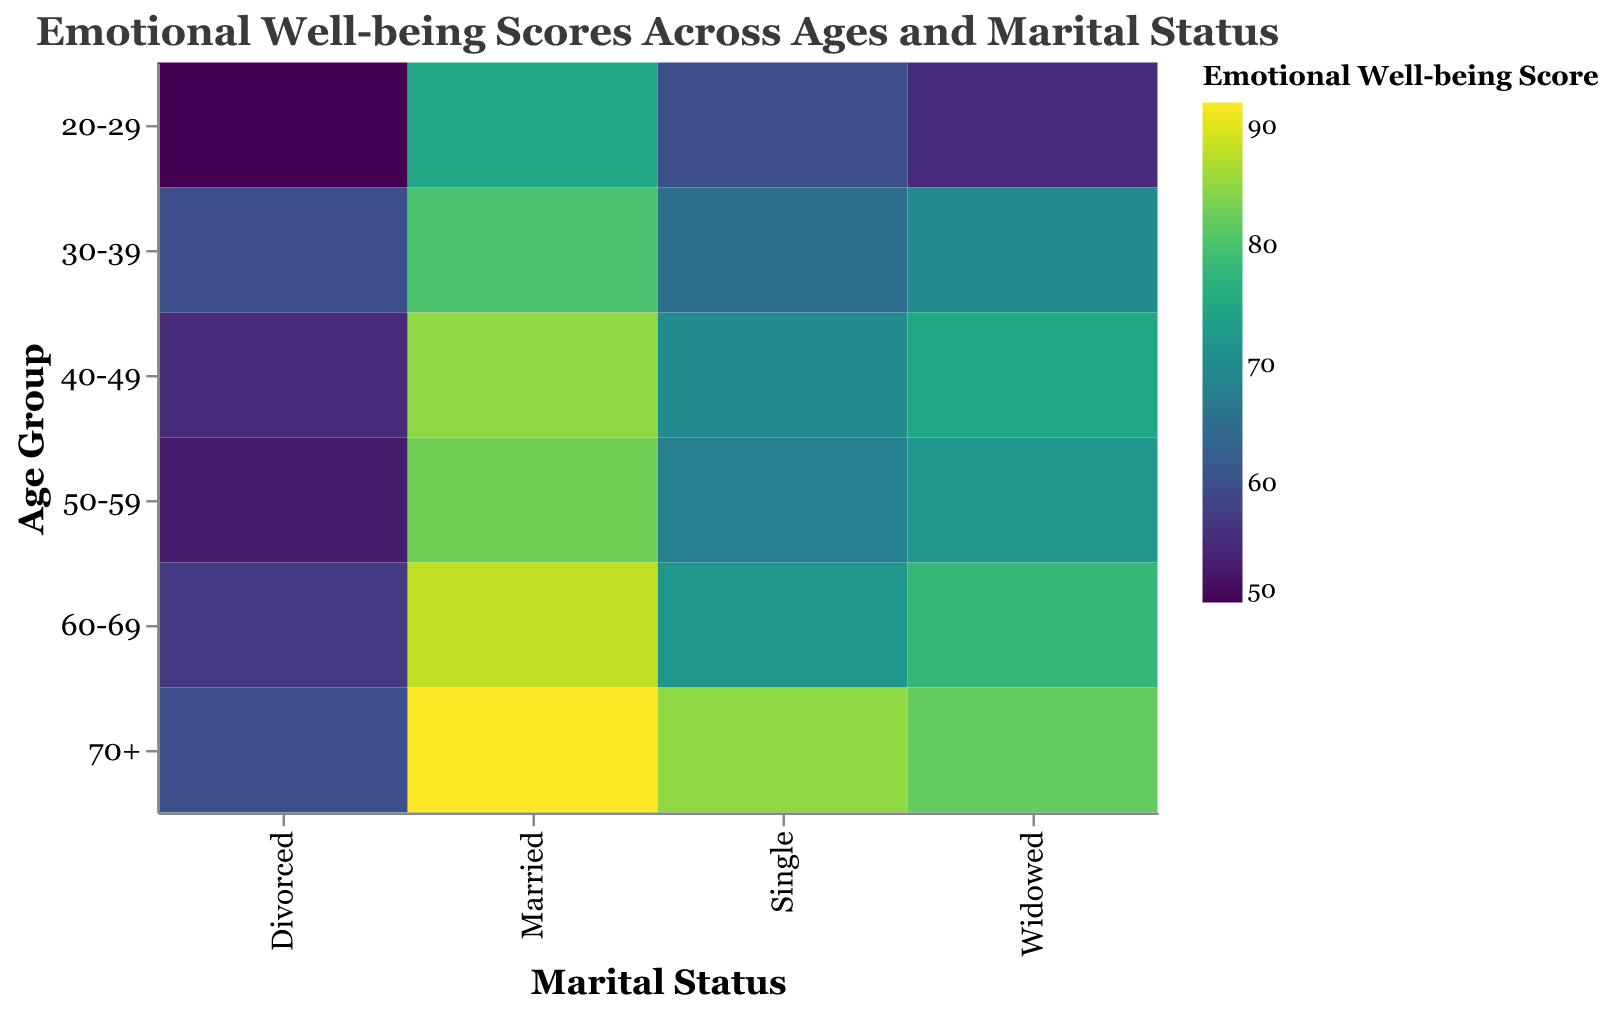What is the title of the heatmap? The title of the heatmap is usually located at the top center of the figure. It summarizes the content of the chart.
Answer: Emotional Well-being Scores Across Ages and Marital Status Which age group has the lowest emotional well-being score for divorced individuals? Looking at the heatmap, find the row labeled "Divorced" and identify the age group with the lowest score within that category.
Answer: 20-29 In which marital status category do individuals aged 70+ have the highest emotional well-being score? Examine the column corresponding to the age group "70+" and find the marital status with the highest score in that row.
Answer: Married Which age group shows the highest emotional well-being score for single individuals? Look at the data for the "Single" category and see which age group has the highest score in that column.
Answer: 70+ What is the difference in emotional well-being scores between married and divorced individuals aged 60-69? Locate the scores for married and divorced individuals in the 60-69 age group and calculate the difference: 88 (Married) - 57 (Divorced).
Answer: 31 Which marital status shows the greatest increase in emotional well-being scores from the 20-29 age group to the 70+ age group? Track the scores for each marital status from the 20-29 age group to the 70+ age group to see which one has the greatest increase.
Answer: Single How do the emotional well-being scores of widowed individuals change across different age groups? Observe the row labeled "Widowed" and describe the trend in scores from the 20-29 age group to the 70+ age group. The scores generally increase as age increases.
Answer: They increase For divorced individuals, what is the average emotional well-being score across all age groups? Add the scores for divorced individuals in each age group and divide by the total number of age groups: (50 + 60 + 55 + 53 + 57 + 60) / 6.
Answer: 55.83 How does the emotional well-being score for single individuals aged 50-59 compare to that of married individuals in the same age group? Compare the scores for single and married individuals in the 50-59 age group by checking the relevant scores: 68 (Single) vs. 83 (Married).
Answer: Married individuals have higher scores What is the overall trend in emotional well-being scores for married individuals as they age? Look at the scores for married individuals across different age groups and describe the trend. The scores consistently increase with age.
Answer: They increase 